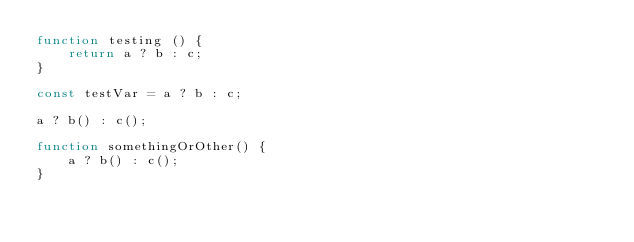<code> <loc_0><loc_0><loc_500><loc_500><_JavaScript_>function testing () {
    return a ? b : c;
}

const testVar = a ? b : c;

a ? b() : c();

function somethingOrOther() {
    a ? b() : c();
}</code> 